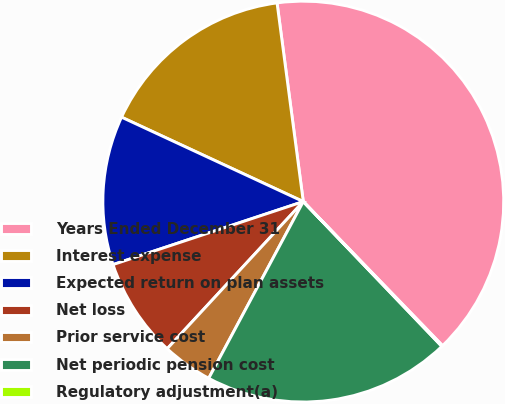Convert chart. <chart><loc_0><loc_0><loc_500><loc_500><pie_chart><fcel>Years Ended December 31<fcel>Interest expense<fcel>Expected return on plan assets<fcel>Net loss<fcel>Prior service cost<fcel>Net periodic pension cost<fcel>Regulatory adjustment(a)<nl><fcel>39.86%<fcel>15.99%<fcel>12.01%<fcel>8.03%<fcel>4.06%<fcel>19.97%<fcel>0.08%<nl></chart> 